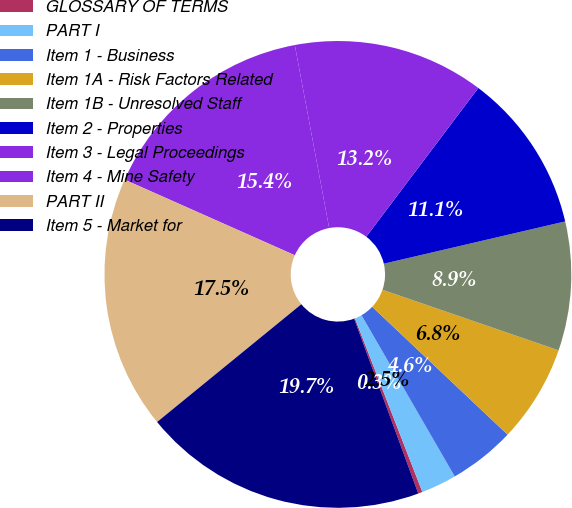<chart> <loc_0><loc_0><loc_500><loc_500><pie_chart><fcel>GLOSSARY OF TERMS<fcel>PART I<fcel>Item 1 - Business<fcel>Item 1A - Risk Factors Related<fcel>Item 1B - Unresolved Staff<fcel>Item 2 - Properties<fcel>Item 3 - Legal Proceedings<fcel>Item 4 - Mine Safety<fcel>PART II<fcel>Item 5 - Market for<nl><fcel>0.3%<fcel>2.45%<fcel>4.61%<fcel>6.77%<fcel>8.92%<fcel>11.08%<fcel>13.23%<fcel>15.39%<fcel>17.55%<fcel>19.7%<nl></chart> 